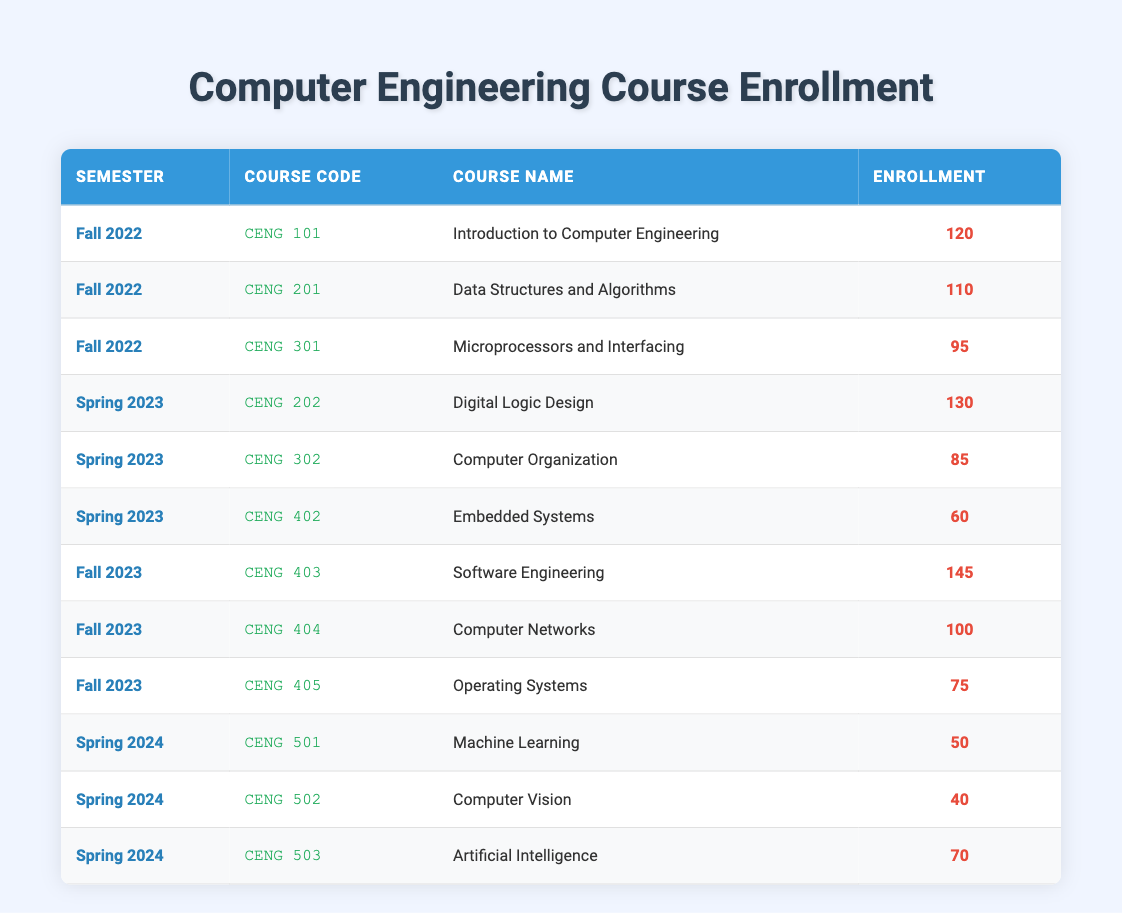What is the enrollment for "Digital Logic Design" in Spring 2023? The enrollment for "Digital Logic Design" is listed in the table under the Spring 2023 semester with a value of 130.
Answer: 130 How many students enrolled in "Operating Systems" in Fall 2023? The table shows that the enrollment count for "Operating Systems" in Fall 2023 is 75.
Answer: 75 Which course had the highest enrollment in Fall 2023? In Fall 2023, "Software Engineering" had the highest enrollment of 145, which is greater than the enrollments of the other courses in that semester.
Answer: Software Engineering What is the total enrollment for the courses in Spring 2024? The enrollment numbers for Spring 2024 are 50 (CENG 501) + 40 (CENG 502) + 70 (CENG 503) = 160, so the total enrollment is 160.
Answer: 160 Was the enrollment for "Embedded Systems" higher than 60? The enrollment for "Embedded Systems" in Spring 2023 is 60, which means it is not higher than 60, it is equal.
Answer: No What is the average enrollment for courses in Fall 2022? The enrollments for Fall 2022 are 120 (CENG 101), 110 (CENG 201), and 95 (CENG 301). Summing these gives 120 + 110 + 95 = 325. Dividing by 3 (the number of courses) gives an average of 325/3 ≈ 108.33.
Answer: Approximately 108.33 Which semester has the lowest enrollment for any course? In Spring 2024, "Computer Vision" has the lowest enrollment at 40, which is lower than any other enrollment recorded in the table data.
Answer: Spring 2024 How many students are enrolled in courses across all semesters that have "Systems" in their course name? The courses with "Systems" in their name are "Embedded Systems" with 60 (Spring 2023) and "Operating Systems" with 75 (Fall 2023). Adding these together gives 60 + 75 = 135.
Answer: 135 Is the total enrollment for Fall 2022 greater than for Spring 2023? The total enrollment for Fall 2022 is 120 + 110 + 95 = 325, while for Spring 2023 it is 130 + 85 + 60 = 275. Since 325 is greater than 275, the statement is true.
Answer: Yes What is the difference in enrollment between the most and least popular courses in Fall 2023? In Fall 2023, "Software Engineering" has the highest enrollment of 145, and "Operating Systems" has the least with 75. The difference is 145 - 75 = 70.
Answer: 70 